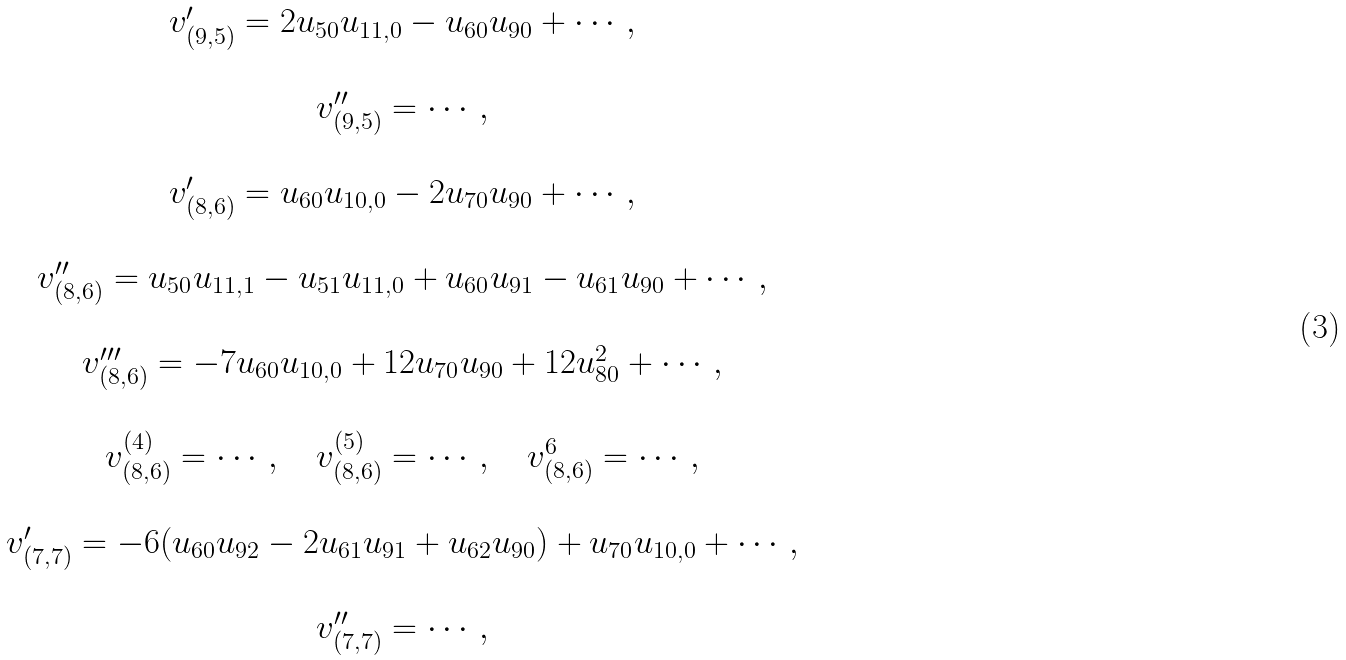Convert formula to latex. <formula><loc_0><loc_0><loc_500><loc_500>\begin{array} { c } v ^ { \prime } _ { ( 9 , 5 ) } = 2 u _ { 5 0 } u _ { 1 1 , 0 } - u _ { 6 0 } u _ { 9 0 } + \cdots , \\ \\ v ^ { \prime \prime } _ { ( 9 , 5 ) } = \cdots , \\ \\ v ^ { \prime } _ { ( 8 , 6 ) } = u _ { 6 0 } u _ { 1 0 , 0 } - 2 u _ { 7 0 } u _ { 9 0 } + \cdots , \\ \\ v ^ { \prime \prime } _ { ( 8 , 6 ) } = u _ { 5 0 } u _ { 1 1 , 1 } - u _ { 5 1 } u _ { 1 1 , 0 } + u _ { 6 0 } u _ { 9 1 } - u _ { 6 1 } u _ { 9 0 } + \cdots , \\ \\ v ^ { \prime \prime \prime } _ { ( 8 , 6 ) } = - 7 u _ { 6 0 } u _ { 1 0 , 0 } + 1 2 u _ { 7 0 } u _ { 9 0 } + 1 2 u _ { 8 0 } ^ { 2 } + \cdots , \\ \\ v ^ { ( 4 ) } _ { ( 8 , 6 ) } = \cdots , \quad v ^ { ( 5 ) } _ { ( 8 , 6 ) } = \cdots , \quad v ^ { 6 } _ { ( 8 , 6 ) } = \cdots , \\ \\ v ^ { \prime } _ { ( 7 , 7 ) } = - 6 ( u _ { 6 0 } u _ { 9 2 } - 2 u _ { 6 1 } u _ { 9 1 } + u _ { 6 2 } u _ { 9 0 } ) + u _ { 7 0 } u _ { 1 0 , 0 } + \cdots , \\ \\ v ^ { \prime \prime } _ { ( 7 , 7 ) } = \cdots , \\ \end{array}</formula> 